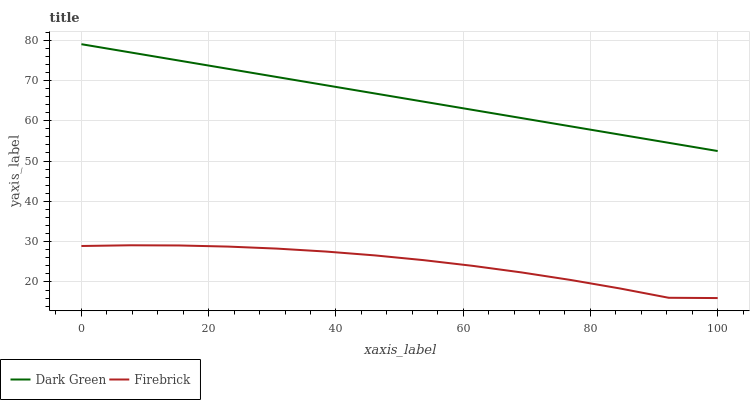Does Firebrick have the minimum area under the curve?
Answer yes or no. Yes. Does Dark Green have the maximum area under the curve?
Answer yes or no. Yes. Does Dark Green have the minimum area under the curve?
Answer yes or no. No. Is Dark Green the smoothest?
Answer yes or no. Yes. Is Firebrick the roughest?
Answer yes or no. Yes. Is Dark Green the roughest?
Answer yes or no. No. Does Firebrick have the lowest value?
Answer yes or no. Yes. Does Dark Green have the lowest value?
Answer yes or no. No. Does Dark Green have the highest value?
Answer yes or no. Yes. Is Firebrick less than Dark Green?
Answer yes or no. Yes. Is Dark Green greater than Firebrick?
Answer yes or no. Yes. Does Firebrick intersect Dark Green?
Answer yes or no. No. 